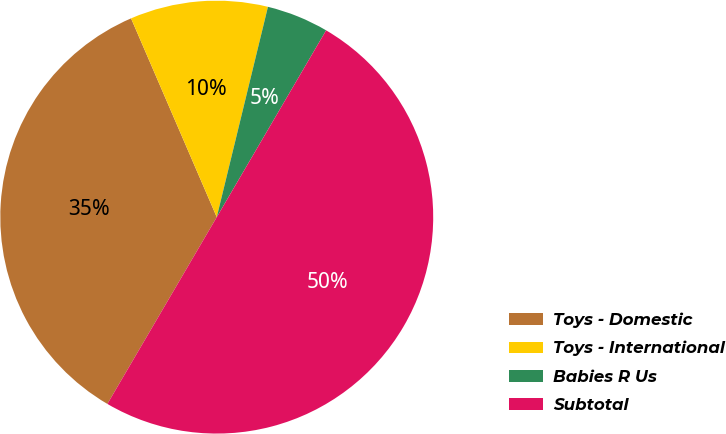Convert chart. <chart><loc_0><loc_0><loc_500><loc_500><pie_chart><fcel>Toys - Domestic<fcel>Toys - International<fcel>Babies R Us<fcel>Subtotal<nl><fcel>35.09%<fcel>10.28%<fcel>4.63%<fcel>50.0%<nl></chart> 